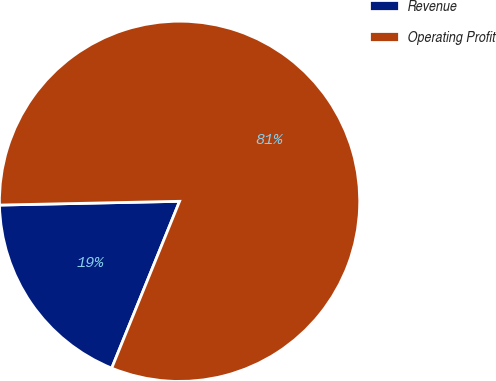Convert chart to OTSL. <chart><loc_0><loc_0><loc_500><loc_500><pie_chart><fcel>Revenue<fcel>Operating Profit<nl><fcel>18.52%<fcel>81.48%<nl></chart> 